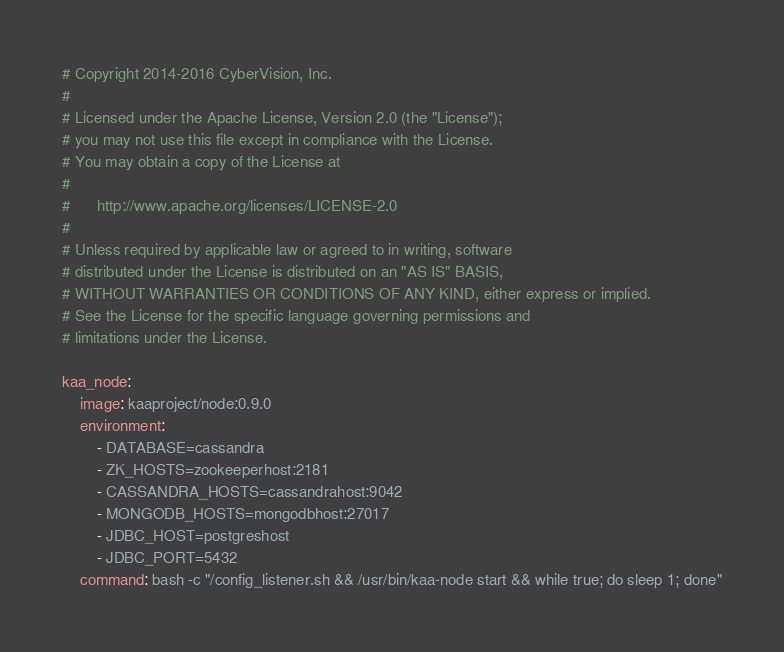Convert code to text. <code><loc_0><loc_0><loc_500><loc_500><_YAML_># Copyright 2014-2016 CyberVision, Inc.
#
# Licensed under the Apache License, Version 2.0 (the "License");
# you may not use this file except in compliance with the License.
# You may obtain a copy of the License at
#
#      http://www.apache.org/licenses/LICENSE-2.0
#
# Unless required by applicable law or agreed to in writing, software
# distributed under the License is distributed on an "AS IS" BASIS,
# WITHOUT WARRANTIES OR CONDITIONS OF ANY KIND, either express or implied.
# See the License for the specific language governing permissions and
# limitations under the License.

kaa_node:
    image: kaaproject/node:0.9.0
    environment:
        - DATABASE=cassandra
        - ZK_HOSTS=zookeeperhost:2181
        - CASSANDRA_HOSTS=cassandrahost:9042
        - MONGODB_HOSTS=mongodbhost:27017
        - JDBC_HOST=postgreshost
        - JDBC_PORT=5432
    command: bash -c "/config_listener.sh && /usr/bin/kaa-node start && while true; do sleep 1; done"
</code> 